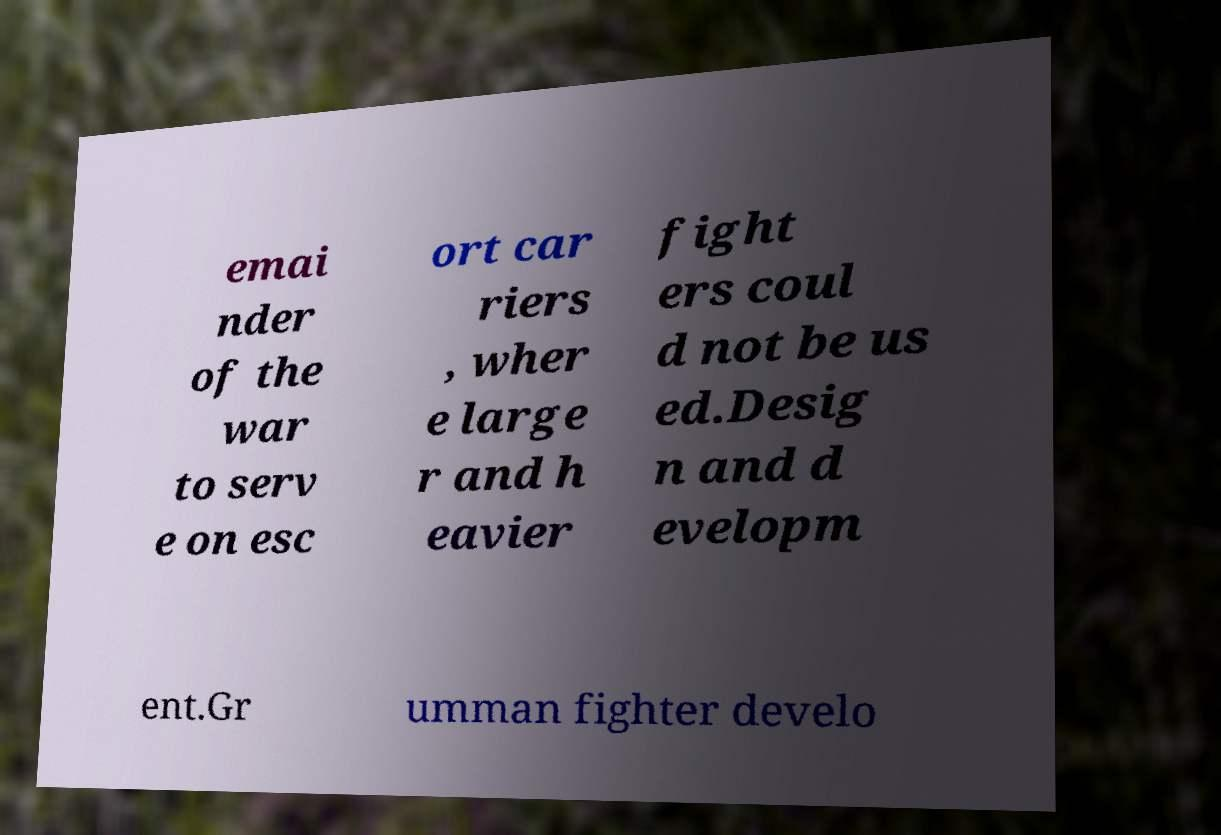Could you assist in decoding the text presented in this image and type it out clearly? emai nder of the war to serv e on esc ort car riers , wher e large r and h eavier fight ers coul d not be us ed.Desig n and d evelopm ent.Gr umman fighter develo 